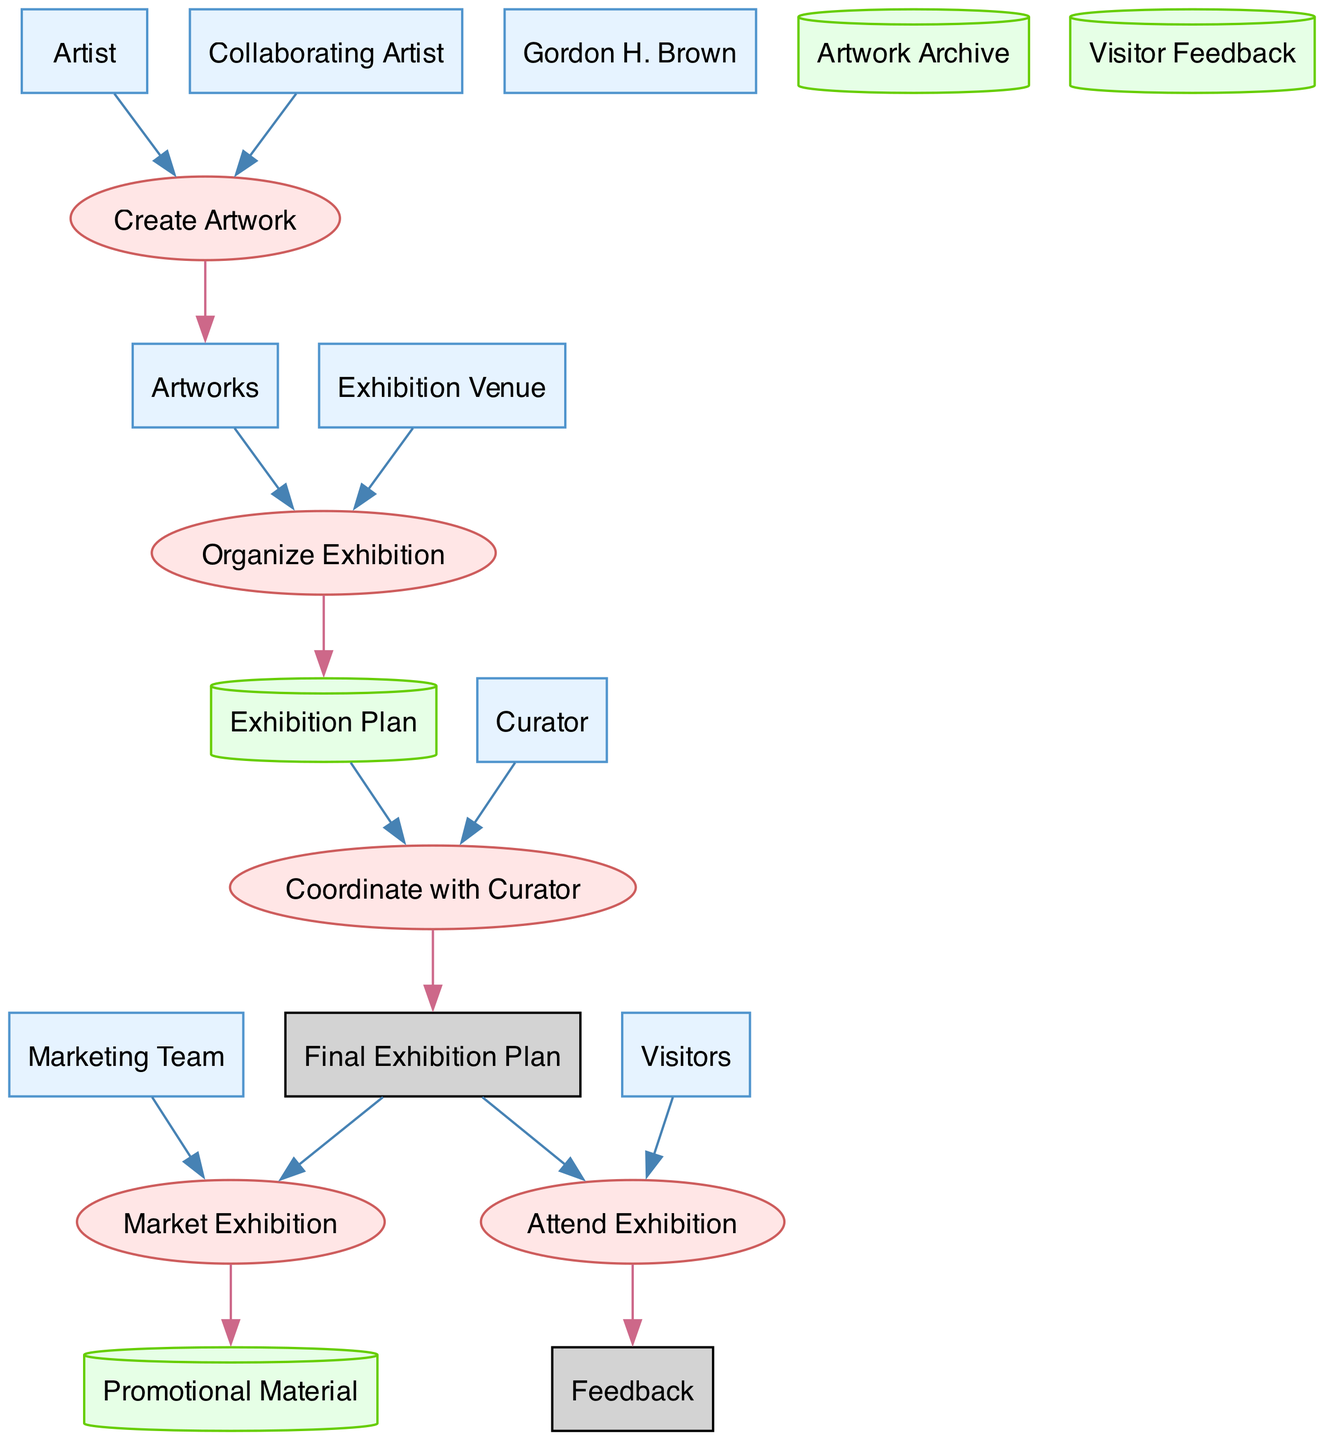What are the output entities of the "Create Artwork" process? The "Create Artwork" process outputs the "Artworks" entity after taking inputs from the "Artist" and "Collaborating Artist".
Answer: Artworks How many entities are present in the diagram? The diagram contains 8 entities, including artists, artworks, exhibition venue, curator, marketing team, and visitors.
Answer: 8 Which process comes after "Organize Exhibition"? The process that follows "Organize Exhibition" is "Coordinate with Curator", which uses the "Exhibition Plan" to create the "Final Exhibition Plan".
Answer: Coordinate with Curator What is the primary input for the "Market Exhibition" process? The "Market Exhibition" process primarily requires the "Final Exhibition Plan" as its input, along with contributions from the "Marketing Team".
Answer: Final Exhibition Plan How many outputs does the "Attend Exhibition" process produce? The "Attend Exhibition" process outputs a single entity, which is "Feedback", collected from the visitors attending the exhibition.
Answer: Feedback Which entity is responsible for organizing the exhibition? The "Curator" is designated as the entity responsible for organizing the exhibition, coordinating with the final plans and other participants.
Answer: Curator What type of data store is "Artwork Archive"? "Artwork Archive" is classified as a cylinder-type data store, representing the storage of all artworks prepared for the exhibition.
Answer: Cylinder What is the connection between "Artworks" and "Exhibition Plan"? "Artworks" serves as an input to the "Organize Exhibition" process, which generates the "Exhibition Plan" based on the artworks and the exhibition venue.
Answer: Input to Organize Exhibition What role does the "Marketing Team" play in the workflow? The "Marketing Team" is crucial in the diagram as it is responsible for creating promotional materials through the "Market Exhibition" process, which uses the "Final Exhibition Plan" as input.
Answer: Promotional materials How are visitors' opinions collected in the workflow? Visitors' opinions are collected through the "Attend Exhibition" process, which gathers "Feedback" as an output after their attendance.
Answer: Feedback 